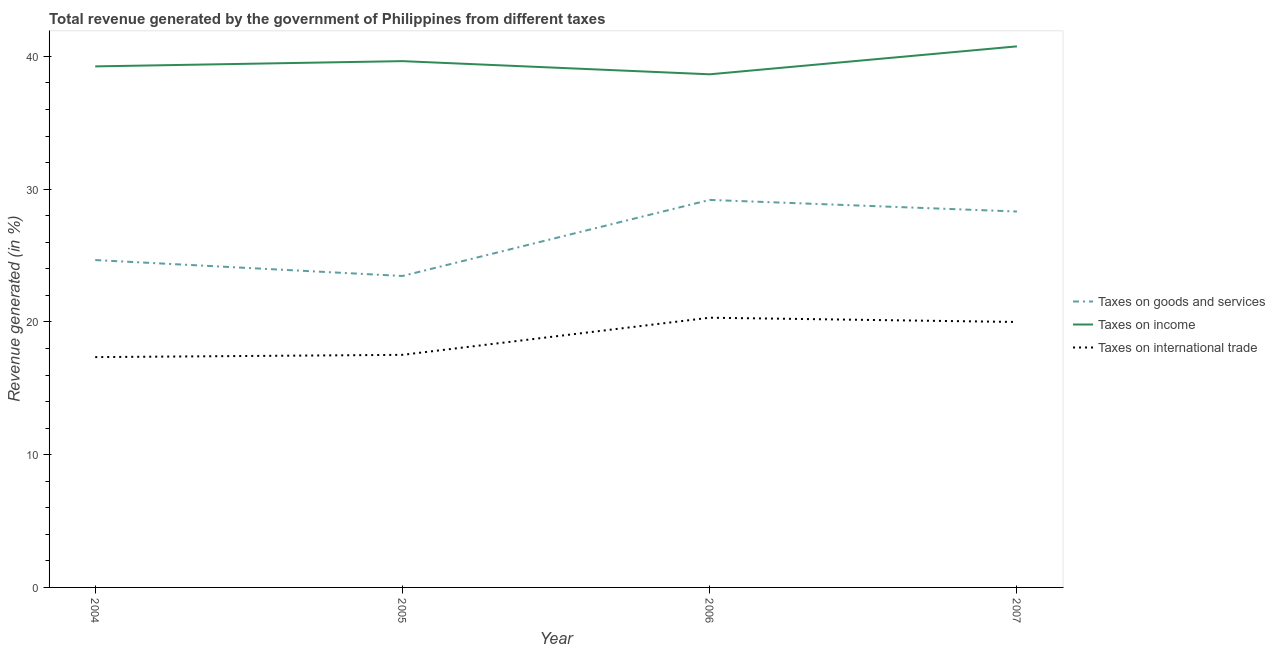What is the percentage of revenue generated by tax on international trade in 2007?
Provide a short and direct response. 19.99. Across all years, what is the maximum percentage of revenue generated by tax on international trade?
Your response must be concise. 20.32. Across all years, what is the minimum percentage of revenue generated by taxes on goods and services?
Offer a very short reply. 23.46. In which year was the percentage of revenue generated by taxes on income maximum?
Your answer should be compact. 2007. What is the total percentage of revenue generated by taxes on income in the graph?
Make the answer very short. 158.29. What is the difference between the percentage of revenue generated by taxes on goods and services in 2006 and that in 2007?
Make the answer very short. 0.87. What is the difference between the percentage of revenue generated by taxes on income in 2007 and the percentage of revenue generated by taxes on goods and services in 2004?
Make the answer very short. 16.1. What is the average percentage of revenue generated by tax on international trade per year?
Your answer should be compact. 18.79. In the year 2004, what is the difference between the percentage of revenue generated by taxes on goods and services and percentage of revenue generated by tax on international trade?
Your answer should be very brief. 7.31. What is the ratio of the percentage of revenue generated by tax on international trade in 2005 to that in 2006?
Offer a very short reply. 0.86. Is the percentage of revenue generated by tax on international trade in 2005 less than that in 2007?
Your answer should be compact. Yes. What is the difference between the highest and the second highest percentage of revenue generated by tax on international trade?
Offer a very short reply. 0.32. What is the difference between the highest and the lowest percentage of revenue generated by taxes on goods and services?
Make the answer very short. 5.73. In how many years, is the percentage of revenue generated by taxes on goods and services greater than the average percentage of revenue generated by taxes on goods and services taken over all years?
Ensure brevity in your answer.  2. Is it the case that in every year, the sum of the percentage of revenue generated by taxes on goods and services and percentage of revenue generated by taxes on income is greater than the percentage of revenue generated by tax on international trade?
Your answer should be very brief. Yes. Is the percentage of revenue generated by tax on international trade strictly less than the percentage of revenue generated by taxes on income over the years?
Make the answer very short. Yes. How many years are there in the graph?
Your response must be concise. 4. Are the values on the major ticks of Y-axis written in scientific E-notation?
Keep it short and to the point. No. Does the graph contain any zero values?
Your response must be concise. No. How are the legend labels stacked?
Keep it short and to the point. Vertical. What is the title of the graph?
Offer a very short reply. Total revenue generated by the government of Philippines from different taxes. What is the label or title of the X-axis?
Ensure brevity in your answer.  Year. What is the label or title of the Y-axis?
Ensure brevity in your answer.  Revenue generated (in %). What is the Revenue generated (in %) of Taxes on goods and services in 2004?
Ensure brevity in your answer.  24.66. What is the Revenue generated (in %) in Taxes on income in 2004?
Make the answer very short. 39.25. What is the Revenue generated (in %) in Taxes on international trade in 2004?
Ensure brevity in your answer.  17.35. What is the Revenue generated (in %) of Taxes on goods and services in 2005?
Give a very brief answer. 23.46. What is the Revenue generated (in %) in Taxes on income in 2005?
Your answer should be very brief. 39.64. What is the Revenue generated (in %) in Taxes on international trade in 2005?
Provide a succinct answer. 17.52. What is the Revenue generated (in %) of Taxes on goods and services in 2006?
Your response must be concise. 29.19. What is the Revenue generated (in %) in Taxes on income in 2006?
Give a very brief answer. 38.65. What is the Revenue generated (in %) in Taxes on international trade in 2006?
Provide a succinct answer. 20.32. What is the Revenue generated (in %) of Taxes on goods and services in 2007?
Provide a succinct answer. 28.31. What is the Revenue generated (in %) of Taxes on income in 2007?
Your response must be concise. 40.75. What is the Revenue generated (in %) in Taxes on international trade in 2007?
Ensure brevity in your answer.  19.99. Across all years, what is the maximum Revenue generated (in %) of Taxes on goods and services?
Make the answer very short. 29.19. Across all years, what is the maximum Revenue generated (in %) of Taxes on income?
Make the answer very short. 40.75. Across all years, what is the maximum Revenue generated (in %) in Taxes on international trade?
Make the answer very short. 20.32. Across all years, what is the minimum Revenue generated (in %) in Taxes on goods and services?
Your response must be concise. 23.46. Across all years, what is the minimum Revenue generated (in %) in Taxes on income?
Keep it short and to the point. 38.65. Across all years, what is the minimum Revenue generated (in %) of Taxes on international trade?
Make the answer very short. 17.35. What is the total Revenue generated (in %) of Taxes on goods and services in the graph?
Your answer should be compact. 105.62. What is the total Revenue generated (in %) in Taxes on income in the graph?
Provide a succinct answer. 158.29. What is the total Revenue generated (in %) of Taxes on international trade in the graph?
Provide a short and direct response. 75.18. What is the difference between the Revenue generated (in %) of Taxes on goods and services in 2004 and that in 2005?
Your answer should be compact. 1.2. What is the difference between the Revenue generated (in %) in Taxes on income in 2004 and that in 2005?
Ensure brevity in your answer.  -0.4. What is the difference between the Revenue generated (in %) of Taxes on international trade in 2004 and that in 2005?
Make the answer very short. -0.17. What is the difference between the Revenue generated (in %) in Taxes on goods and services in 2004 and that in 2006?
Offer a terse response. -4.53. What is the difference between the Revenue generated (in %) in Taxes on income in 2004 and that in 2006?
Offer a very short reply. 0.6. What is the difference between the Revenue generated (in %) in Taxes on international trade in 2004 and that in 2006?
Your answer should be very brief. -2.97. What is the difference between the Revenue generated (in %) of Taxes on goods and services in 2004 and that in 2007?
Provide a succinct answer. -3.66. What is the difference between the Revenue generated (in %) of Taxes on income in 2004 and that in 2007?
Ensure brevity in your answer.  -1.51. What is the difference between the Revenue generated (in %) of Taxes on international trade in 2004 and that in 2007?
Make the answer very short. -2.65. What is the difference between the Revenue generated (in %) of Taxes on goods and services in 2005 and that in 2006?
Ensure brevity in your answer.  -5.73. What is the difference between the Revenue generated (in %) in Taxes on income in 2005 and that in 2006?
Make the answer very short. 0.99. What is the difference between the Revenue generated (in %) of Taxes on international trade in 2005 and that in 2006?
Provide a succinct answer. -2.8. What is the difference between the Revenue generated (in %) in Taxes on goods and services in 2005 and that in 2007?
Ensure brevity in your answer.  -4.86. What is the difference between the Revenue generated (in %) of Taxes on income in 2005 and that in 2007?
Provide a short and direct response. -1.11. What is the difference between the Revenue generated (in %) in Taxes on international trade in 2005 and that in 2007?
Give a very brief answer. -2.48. What is the difference between the Revenue generated (in %) in Taxes on goods and services in 2006 and that in 2007?
Give a very brief answer. 0.87. What is the difference between the Revenue generated (in %) of Taxes on income in 2006 and that in 2007?
Your answer should be compact. -2.1. What is the difference between the Revenue generated (in %) of Taxes on international trade in 2006 and that in 2007?
Provide a short and direct response. 0.32. What is the difference between the Revenue generated (in %) in Taxes on goods and services in 2004 and the Revenue generated (in %) in Taxes on income in 2005?
Offer a very short reply. -14.98. What is the difference between the Revenue generated (in %) of Taxes on goods and services in 2004 and the Revenue generated (in %) of Taxes on international trade in 2005?
Ensure brevity in your answer.  7.14. What is the difference between the Revenue generated (in %) of Taxes on income in 2004 and the Revenue generated (in %) of Taxes on international trade in 2005?
Offer a very short reply. 21.73. What is the difference between the Revenue generated (in %) of Taxes on goods and services in 2004 and the Revenue generated (in %) of Taxes on income in 2006?
Provide a short and direct response. -13.99. What is the difference between the Revenue generated (in %) in Taxes on goods and services in 2004 and the Revenue generated (in %) in Taxes on international trade in 2006?
Provide a short and direct response. 4.34. What is the difference between the Revenue generated (in %) of Taxes on income in 2004 and the Revenue generated (in %) of Taxes on international trade in 2006?
Provide a short and direct response. 18.93. What is the difference between the Revenue generated (in %) of Taxes on goods and services in 2004 and the Revenue generated (in %) of Taxes on income in 2007?
Give a very brief answer. -16.1. What is the difference between the Revenue generated (in %) in Taxes on goods and services in 2004 and the Revenue generated (in %) in Taxes on international trade in 2007?
Provide a short and direct response. 4.66. What is the difference between the Revenue generated (in %) in Taxes on income in 2004 and the Revenue generated (in %) in Taxes on international trade in 2007?
Keep it short and to the point. 19.25. What is the difference between the Revenue generated (in %) of Taxes on goods and services in 2005 and the Revenue generated (in %) of Taxes on income in 2006?
Ensure brevity in your answer.  -15.19. What is the difference between the Revenue generated (in %) of Taxes on goods and services in 2005 and the Revenue generated (in %) of Taxes on international trade in 2006?
Keep it short and to the point. 3.14. What is the difference between the Revenue generated (in %) of Taxes on income in 2005 and the Revenue generated (in %) of Taxes on international trade in 2006?
Keep it short and to the point. 19.33. What is the difference between the Revenue generated (in %) of Taxes on goods and services in 2005 and the Revenue generated (in %) of Taxes on income in 2007?
Your answer should be compact. -17.3. What is the difference between the Revenue generated (in %) in Taxes on goods and services in 2005 and the Revenue generated (in %) in Taxes on international trade in 2007?
Ensure brevity in your answer.  3.46. What is the difference between the Revenue generated (in %) of Taxes on income in 2005 and the Revenue generated (in %) of Taxes on international trade in 2007?
Keep it short and to the point. 19.65. What is the difference between the Revenue generated (in %) in Taxes on goods and services in 2006 and the Revenue generated (in %) in Taxes on income in 2007?
Make the answer very short. -11.57. What is the difference between the Revenue generated (in %) of Taxes on goods and services in 2006 and the Revenue generated (in %) of Taxes on international trade in 2007?
Your response must be concise. 9.19. What is the difference between the Revenue generated (in %) of Taxes on income in 2006 and the Revenue generated (in %) of Taxes on international trade in 2007?
Give a very brief answer. 18.66. What is the average Revenue generated (in %) of Taxes on goods and services per year?
Offer a terse response. 26.41. What is the average Revenue generated (in %) of Taxes on income per year?
Make the answer very short. 39.57. What is the average Revenue generated (in %) of Taxes on international trade per year?
Offer a very short reply. 18.79. In the year 2004, what is the difference between the Revenue generated (in %) of Taxes on goods and services and Revenue generated (in %) of Taxes on income?
Provide a succinct answer. -14.59. In the year 2004, what is the difference between the Revenue generated (in %) of Taxes on goods and services and Revenue generated (in %) of Taxes on international trade?
Keep it short and to the point. 7.31. In the year 2004, what is the difference between the Revenue generated (in %) in Taxes on income and Revenue generated (in %) in Taxes on international trade?
Your answer should be very brief. 21.9. In the year 2005, what is the difference between the Revenue generated (in %) in Taxes on goods and services and Revenue generated (in %) in Taxes on income?
Offer a very short reply. -16.18. In the year 2005, what is the difference between the Revenue generated (in %) of Taxes on goods and services and Revenue generated (in %) of Taxes on international trade?
Offer a terse response. 5.94. In the year 2005, what is the difference between the Revenue generated (in %) in Taxes on income and Revenue generated (in %) in Taxes on international trade?
Offer a terse response. 22.12. In the year 2006, what is the difference between the Revenue generated (in %) of Taxes on goods and services and Revenue generated (in %) of Taxes on income?
Your answer should be compact. -9.46. In the year 2006, what is the difference between the Revenue generated (in %) in Taxes on goods and services and Revenue generated (in %) in Taxes on international trade?
Give a very brief answer. 8.87. In the year 2006, what is the difference between the Revenue generated (in %) in Taxes on income and Revenue generated (in %) in Taxes on international trade?
Make the answer very short. 18.33. In the year 2007, what is the difference between the Revenue generated (in %) of Taxes on goods and services and Revenue generated (in %) of Taxes on income?
Give a very brief answer. -12.44. In the year 2007, what is the difference between the Revenue generated (in %) of Taxes on goods and services and Revenue generated (in %) of Taxes on international trade?
Ensure brevity in your answer.  8.32. In the year 2007, what is the difference between the Revenue generated (in %) in Taxes on income and Revenue generated (in %) in Taxes on international trade?
Ensure brevity in your answer.  20.76. What is the ratio of the Revenue generated (in %) of Taxes on goods and services in 2004 to that in 2005?
Ensure brevity in your answer.  1.05. What is the ratio of the Revenue generated (in %) of Taxes on international trade in 2004 to that in 2005?
Offer a terse response. 0.99. What is the ratio of the Revenue generated (in %) of Taxes on goods and services in 2004 to that in 2006?
Offer a very short reply. 0.84. What is the ratio of the Revenue generated (in %) in Taxes on income in 2004 to that in 2006?
Provide a short and direct response. 1.02. What is the ratio of the Revenue generated (in %) of Taxes on international trade in 2004 to that in 2006?
Make the answer very short. 0.85. What is the ratio of the Revenue generated (in %) of Taxes on goods and services in 2004 to that in 2007?
Your answer should be very brief. 0.87. What is the ratio of the Revenue generated (in %) in Taxes on income in 2004 to that in 2007?
Keep it short and to the point. 0.96. What is the ratio of the Revenue generated (in %) of Taxes on international trade in 2004 to that in 2007?
Provide a short and direct response. 0.87. What is the ratio of the Revenue generated (in %) in Taxes on goods and services in 2005 to that in 2006?
Keep it short and to the point. 0.8. What is the ratio of the Revenue generated (in %) of Taxes on income in 2005 to that in 2006?
Your response must be concise. 1.03. What is the ratio of the Revenue generated (in %) in Taxes on international trade in 2005 to that in 2006?
Offer a terse response. 0.86. What is the ratio of the Revenue generated (in %) in Taxes on goods and services in 2005 to that in 2007?
Provide a succinct answer. 0.83. What is the ratio of the Revenue generated (in %) in Taxes on income in 2005 to that in 2007?
Your response must be concise. 0.97. What is the ratio of the Revenue generated (in %) of Taxes on international trade in 2005 to that in 2007?
Offer a very short reply. 0.88. What is the ratio of the Revenue generated (in %) of Taxes on goods and services in 2006 to that in 2007?
Your answer should be very brief. 1.03. What is the ratio of the Revenue generated (in %) in Taxes on income in 2006 to that in 2007?
Give a very brief answer. 0.95. What is the ratio of the Revenue generated (in %) in Taxes on international trade in 2006 to that in 2007?
Your answer should be compact. 1.02. What is the difference between the highest and the second highest Revenue generated (in %) in Taxes on goods and services?
Make the answer very short. 0.87. What is the difference between the highest and the second highest Revenue generated (in %) in Taxes on income?
Your answer should be compact. 1.11. What is the difference between the highest and the second highest Revenue generated (in %) in Taxes on international trade?
Provide a short and direct response. 0.32. What is the difference between the highest and the lowest Revenue generated (in %) of Taxes on goods and services?
Make the answer very short. 5.73. What is the difference between the highest and the lowest Revenue generated (in %) of Taxes on income?
Make the answer very short. 2.1. What is the difference between the highest and the lowest Revenue generated (in %) in Taxes on international trade?
Give a very brief answer. 2.97. 